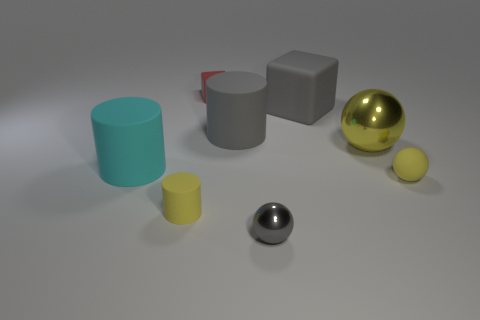There is a small yellow thing to the right of the gray shiny object; what number of yellow objects are in front of it?
Provide a succinct answer. 1. What is the color of the rubber object that is the same shape as the yellow shiny thing?
Give a very brief answer. Yellow. Are the large yellow sphere and the cyan object made of the same material?
Your answer should be compact. No. What number of balls are either cyan things or gray shiny objects?
Your answer should be very brief. 1. What size is the gray matte thing that is on the left side of the ball in front of the matte thing to the right of the large shiny ball?
Provide a succinct answer. Large. The yellow rubber thing that is the same shape as the yellow metal object is what size?
Offer a very short reply. Small. What number of large matte objects are in front of the small gray metal ball?
Provide a succinct answer. 0. There is a tiny rubber object to the right of the gray metal object; is it the same color as the tiny cylinder?
Offer a very short reply. Yes. What number of gray objects are matte spheres or large spheres?
Your answer should be compact. 0. There is a matte cylinder that is on the right side of the rubber cube that is behind the large cube; what color is it?
Provide a short and direct response. Gray. 